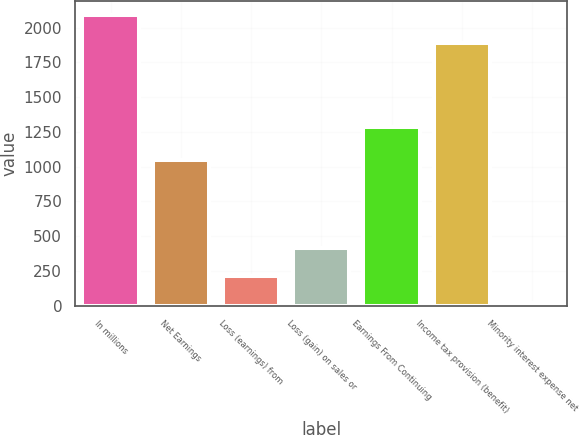Convert chart. <chart><loc_0><loc_0><loc_500><loc_500><bar_chart><fcel>In millions<fcel>Net Earnings<fcel>Loss (earnings) from<fcel>Loss (gain) on sales or<fcel>Earnings From Continuing<fcel>Income tax provision (benefit)<fcel>Minority interest expense net<nl><fcel>2087.9<fcel>1050<fcel>215.9<fcel>414.8<fcel>1282<fcel>1889<fcel>17<nl></chart> 